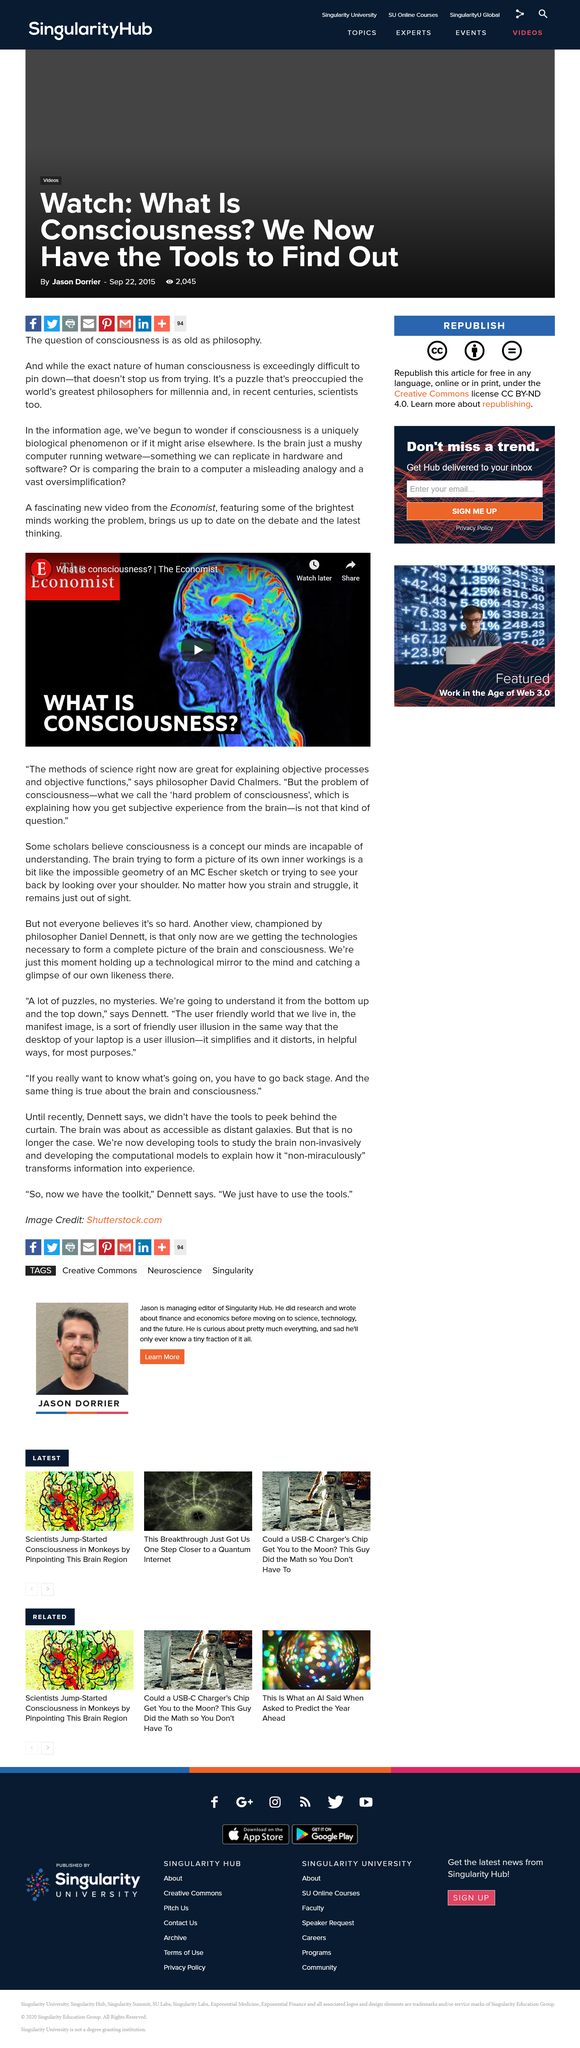Highlight a few significant elements in this photo. The Economist provides a video on the subject that can be found in publications. The article suggests that we now have the tools necessary to determine the nature of consciousness. The question of consciousness is being examined in this article by Jason Dorrier. 